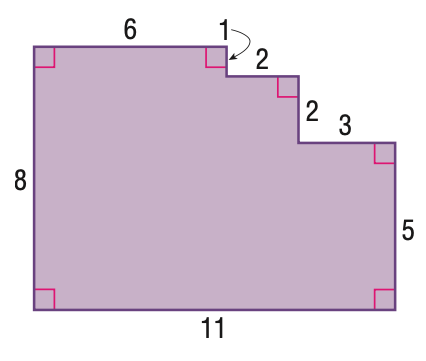Answer the mathemtical geometry problem and directly provide the correct option letter.
Question: Find the area of the figure.
Choices: A: 73 B: 77 C: 80 D: 88 B 